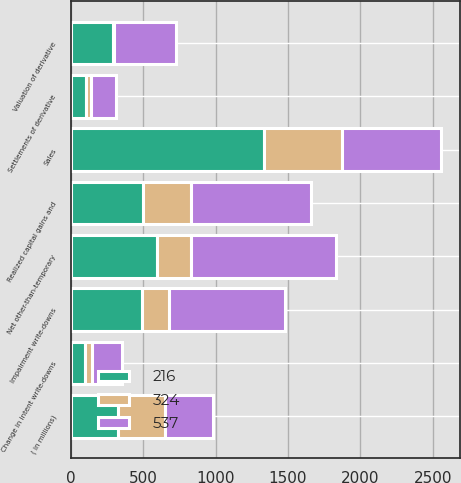Convert chart to OTSL. <chart><loc_0><loc_0><loc_500><loc_500><stacked_bar_chart><ecel><fcel>( in millions)<fcel>Impairment write-downs<fcel>Change in intent write-downs<fcel>Net other-than-temporary<fcel>Sales<fcel>Valuation of derivative<fcel>Settlements of derivative<fcel>Realized capital gains and<nl><fcel>324<fcel>327<fcel>185<fcel>48<fcel>233<fcel>536<fcel>11<fcel>35<fcel>327<nl><fcel>216<fcel>327<fcel>496<fcel>100<fcel>596<fcel>1336<fcel>291<fcel>105<fcel>503<nl><fcel>537<fcel>327<fcel>797<fcel>204<fcel>1001<fcel>686<fcel>427<fcel>174<fcel>827<nl></chart> 